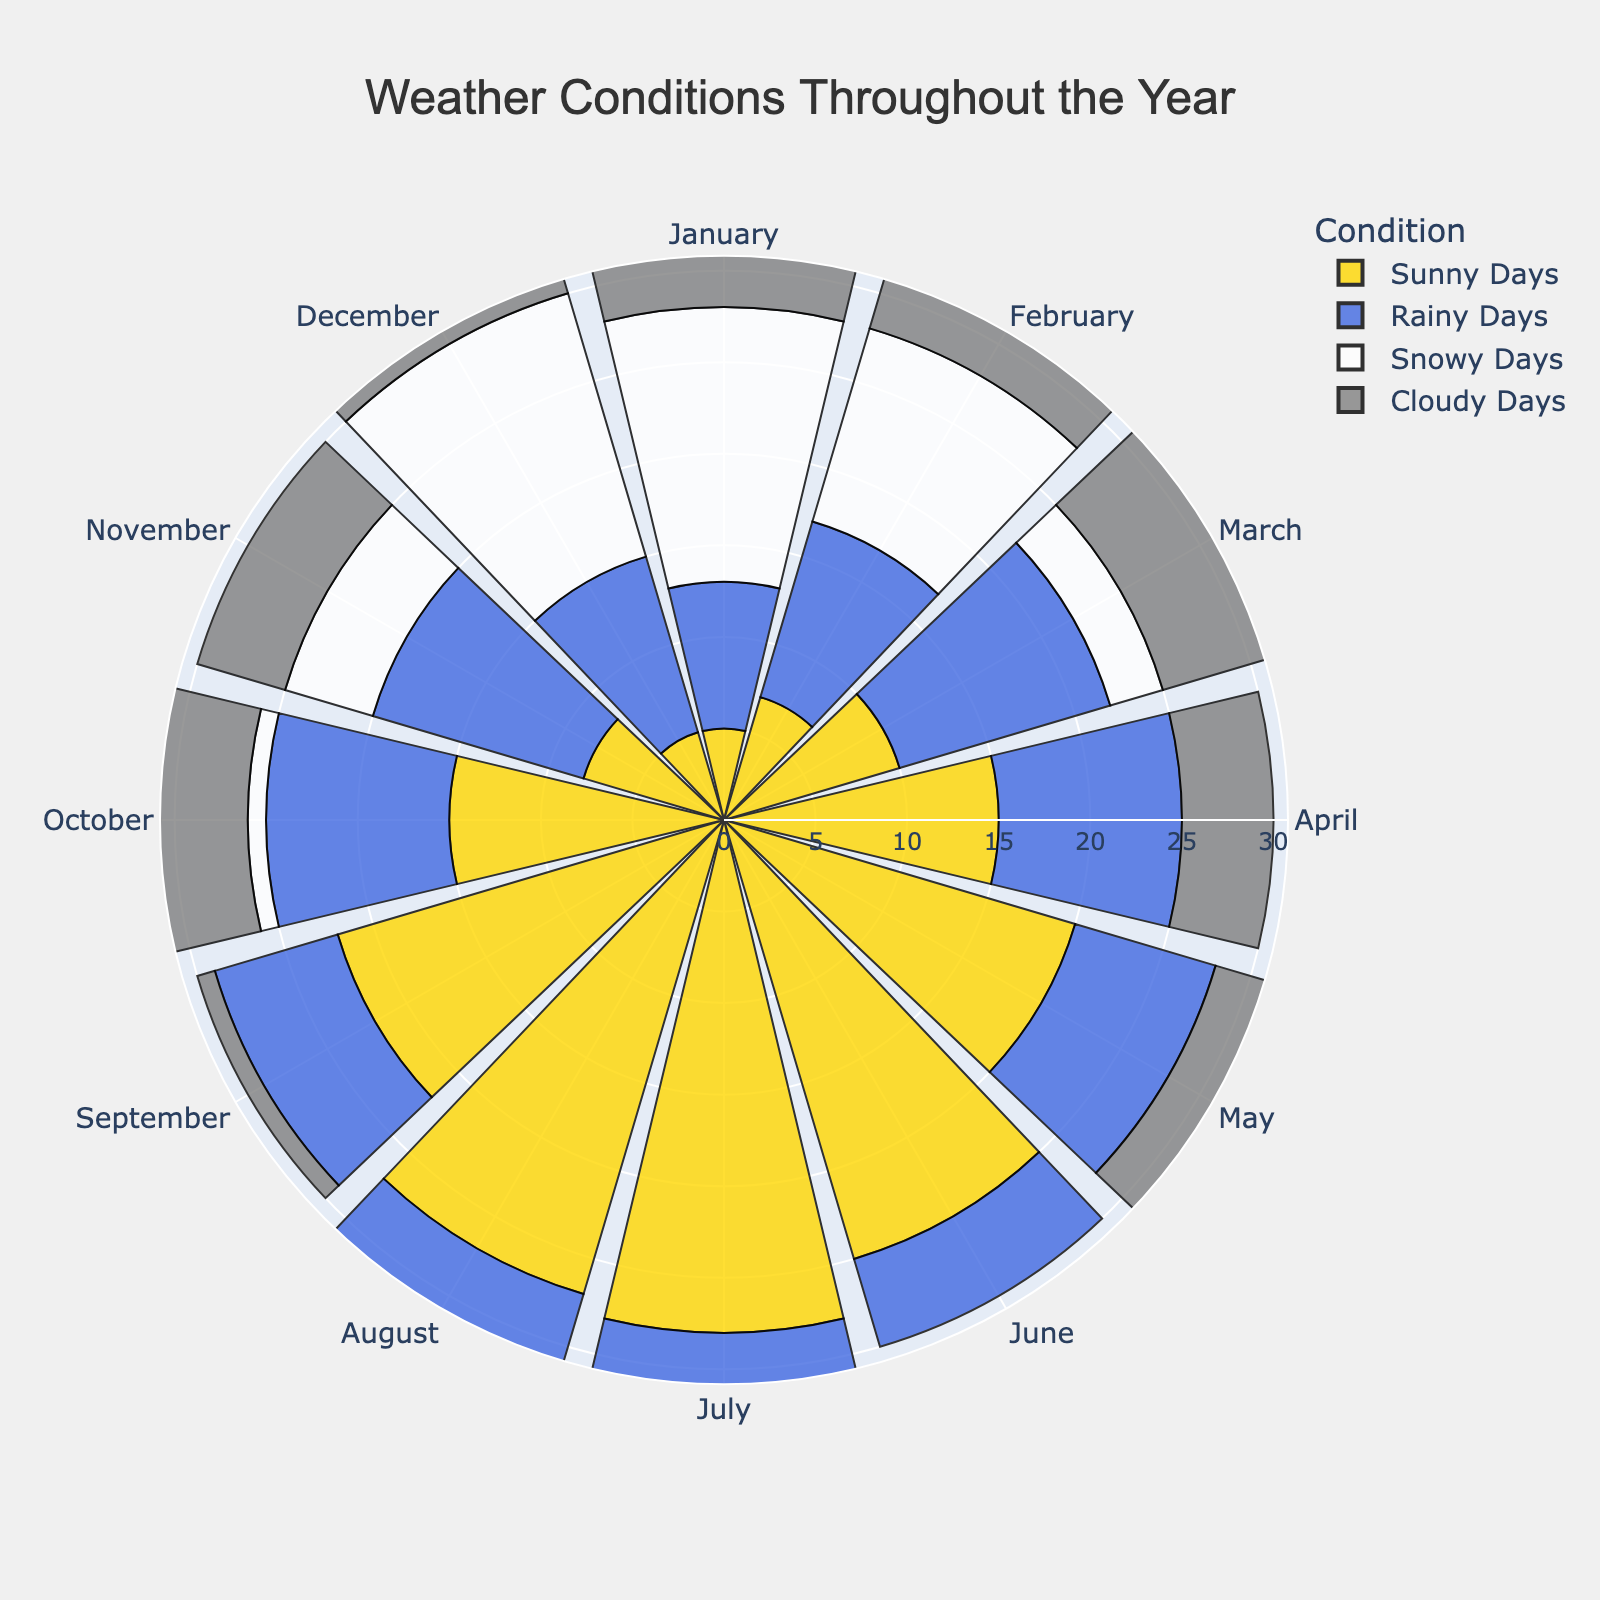What are the names of the different weather conditions represented in the plot? The weather conditions are represented by different colors in the plot, and the legend can be referred to for reading them. The names listed in the legend are Sunny Days, Rainy Days, Snowy Days, and Cloudy Days.
Answer: Sunny Days, Rainy Days, Snowy Days, Cloudy Days Which weather condition has the highest number of days in July? By examining the radial bars for the month of July, the yellow-colored bar, representing Sunny Days, has the highest number of days.
Answer: Sunny Days How many snowy days are there in the first quarter of the year (January, February, March) combined? Add the snowy days for January (15), February (11), and March (3): 15 + 11 + 3 = 29.
Answer: 29 Compare the number of sunny days in January and June. Which month has more sunny days? In January, there are 5 sunny days, and in June, there are 25 sunny days as indicated by the bars. June has more sunny days compared to January.
Answer: June What is the total number of weather conditions recorded in October? Sum the values for October: 15 sunny + 10 rainy + 1 snowy + 5 cloudy = 31 days.
Answer: 31 Which month has the highest number of cloudy days? By observing the bars for cloudy days, December and February each have 6 cloudy days, which is the highest over all months.
Answer: December and February Which weather condition is least common in April? In April, the snowy days bar is absent (value is 0), which indicates Snowy Days are the least common.
Answer: Snowy Days How does the number of sunny days in September compare to August? In September, there are 22 sunny days, while in August, there are 27 sunny days. Thus, August has more sunny days than September.
Answer: August Calculate the average number of rainy days over the entire year? Add the number of rainy days for each month: 8 + 10 + 12 + 10 + 8 + 5 + 3 + 4 + 7 + 10 + 12 + 10 = 99. There are 12 months, so the average is 99 / 12 ≈ 8.25.
Answer: 8.25 Identify the month with the highest variability in weather conditions and explain how you determined it. This can be identified by looking at the month with the widest range of values for the different conditions. November has 8 sunny, 12 rainy, 5 snowy, and 5 cloudy days, showing high variability (from 5 to 12 days, spread across four conditions).
Answer: November 